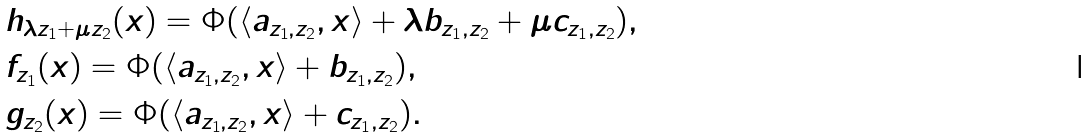<formula> <loc_0><loc_0><loc_500><loc_500>& h _ { \lambda z _ { 1 } + \mu z _ { 2 } } ( x ) = \Phi ( \langle a _ { z _ { 1 } , z _ { 2 } } , x \rangle + \lambda b _ { z _ { 1 } , z _ { 2 } } + \mu c _ { z _ { 1 } , z _ { 2 } } ) , \\ & f _ { z _ { 1 } } ( x ) = \Phi ( \langle a _ { z _ { 1 } , z _ { 2 } } , x \rangle + b _ { z _ { 1 } , z _ { 2 } } ) , \\ & g _ { z _ { 2 } } ( x ) = \Phi ( \langle a _ { z _ { 1 } , z _ { 2 } } , x \rangle + c _ { z _ { 1 } , z _ { 2 } } ) .</formula> 